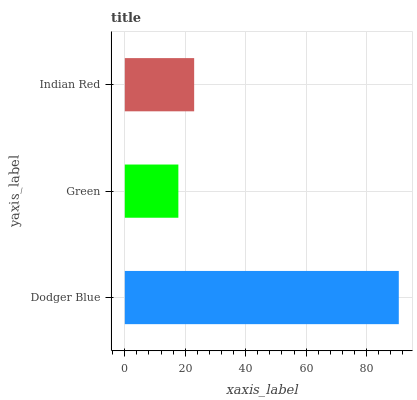Is Green the minimum?
Answer yes or no. Yes. Is Dodger Blue the maximum?
Answer yes or no. Yes. Is Indian Red the minimum?
Answer yes or no. No. Is Indian Red the maximum?
Answer yes or no. No. Is Indian Red greater than Green?
Answer yes or no. Yes. Is Green less than Indian Red?
Answer yes or no. Yes. Is Green greater than Indian Red?
Answer yes or no. No. Is Indian Red less than Green?
Answer yes or no. No. Is Indian Red the high median?
Answer yes or no. Yes. Is Indian Red the low median?
Answer yes or no. Yes. Is Dodger Blue the high median?
Answer yes or no. No. Is Dodger Blue the low median?
Answer yes or no. No. 